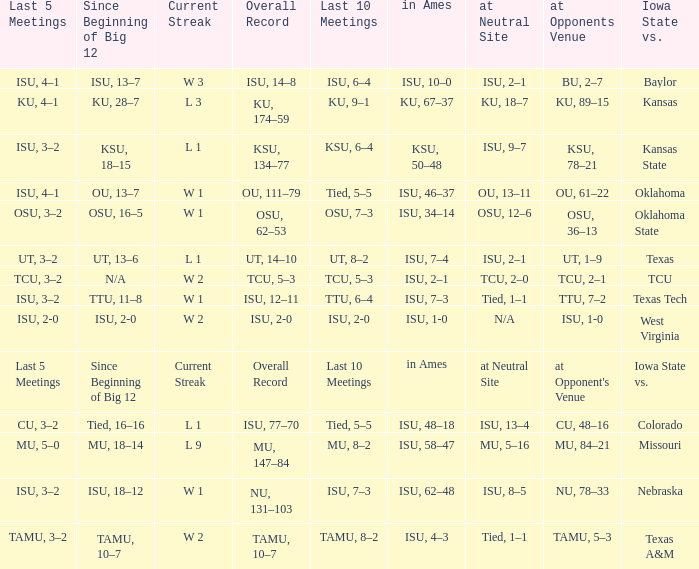When the value of "since beginning of big 12" is synonymous with its' category, what are the in Ames values? In ames. Would you mind parsing the complete table? {'header': ['Last 5 Meetings', 'Since Beginning of Big 12', 'Current Streak', 'Overall Record', 'Last 10 Meetings', 'in Ames', 'at Neutral Site', 'at Opponents Venue', 'Iowa State vs.'], 'rows': [['ISU, 4–1', 'ISU, 13–7', 'W 3', 'ISU, 14–8', 'ISU, 6–4', 'ISU, 10–0', 'ISU, 2–1', 'BU, 2–7', 'Baylor'], ['KU, 4–1', 'KU, 28–7', 'L 3', 'KU, 174–59', 'KU, 9–1', 'KU, 67–37', 'KU, 18–7', 'KU, 89–15', 'Kansas'], ['ISU, 3–2', 'KSU, 18–15', 'L 1', 'KSU, 134–77', 'KSU, 6–4', 'KSU, 50–48', 'ISU, 9–7', 'KSU, 78–21', 'Kansas State'], ['ISU, 4–1', 'OU, 13–7', 'W 1', 'OU, 111–79', 'Tied, 5–5', 'ISU, 46–37', 'OU, 13–11', 'OU, 61–22', 'Oklahoma'], ['OSU, 3–2', 'OSU, 16–5', 'W 1', 'OSU, 62–53', 'OSU, 7–3', 'ISU, 34–14', 'OSU, 12–6', 'OSU, 36–13', 'Oklahoma State'], ['UT, 3–2', 'UT, 13–6', 'L 1', 'UT, 14–10', 'UT, 8–2', 'ISU, 7–4', 'ISU, 2–1', 'UT, 1–9', 'Texas'], ['TCU, 3–2', 'N/A', 'W 2', 'TCU, 5–3', 'TCU, 5–3', 'ISU, 2–1', 'TCU, 2–0', 'TCU, 2–1', 'TCU'], ['ISU, 3–2', 'TTU, 11–8', 'W 1', 'ISU, 12–11', 'TTU, 6–4', 'ISU, 7–3', 'Tied, 1–1', 'TTU, 7–2', 'Texas Tech'], ['ISU, 2-0', 'ISU, 2-0', 'W 2', 'ISU, 2-0', 'ISU, 2-0', 'ISU, 1-0', 'N/A', 'ISU, 1-0', 'West Virginia'], ['Last 5 Meetings', 'Since Beginning of Big 12', 'Current Streak', 'Overall Record', 'Last 10 Meetings', 'in Ames', 'at Neutral Site', "at Opponent's Venue", 'Iowa State vs.'], ['CU, 3–2', 'Tied, 16–16', 'L 1', 'ISU, 77–70', 'Tied, 5–5', 'ISU, 48–18', 'ISU, 13–4', 'CU, 48–16', 'Colorado'], ['MU, 5–0', 'MU, 18–14', 'L 9', 'MU, 147–84', 'MU, 8–2', 'ISU, 58–47', 'MU, 5–16', 'MU, 84–21', 'Missouri'], ['ISU, 3–2', 'ISU, 18–12', 'W 1', 'NU, 131–103', 'ISU, 7–3', 'ISU, 62–48', 'ISU, 8–5', 'NU, 78–33', 'Nebraska'], ['TAMU, 3–2', 'TAMU, 10–7', 'W 2', 'TAMU, 10–7', 'TAMU, 8–2', 'ISU, 4–3', 'Tied, 1–1', 'TAMU, 5–3', 'Texas A&M']]} 